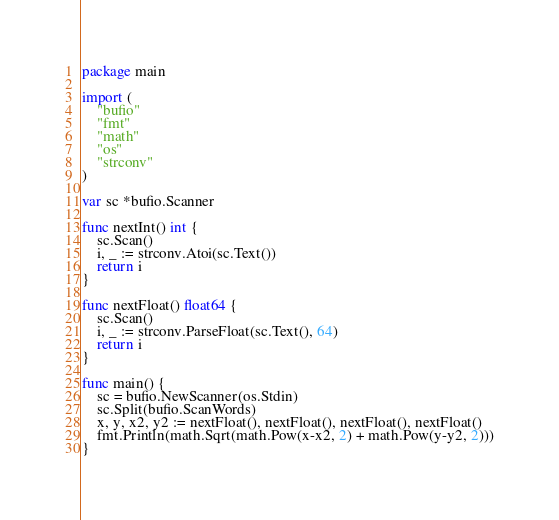Convert code to text. <code><loc_0><loc_0><loc_500><loc_500><_Go_>package main

import (
	"bufio"
	"fmt"
	"math"
	"os"
	"strconv"
)

var sc *bufio.Scanner

func nextInt() int {
	sc.Scan()
	i, _ := strconv.Atoi(sc.Text())
	return i
}

func nextFloat() float64 {
	sc.Scan()
	i, _ := strconv.ParseFloat(sc.Text(), 64)
	return i
}

func main() {
	sc = bufio.NewScanner(os.Stdin)
	sc.Split(bufio.ScanWords)
	x, y, x2, y2 := nextFloat(), nextFloat(), nextFloat(), nextFloat()
	fmt.Println(math.Sqrt(math.Pow(x-x2, 2) + math.Pow(y-y2, 2)))
}

</code> 